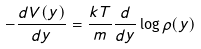<formula> <loc_0><loc_0><loc_500><loc_500>- \frac { d V ( y ) } { d y } = \frac { k T } m \frac { d } { d y } \log \rho ( y )</formula> 